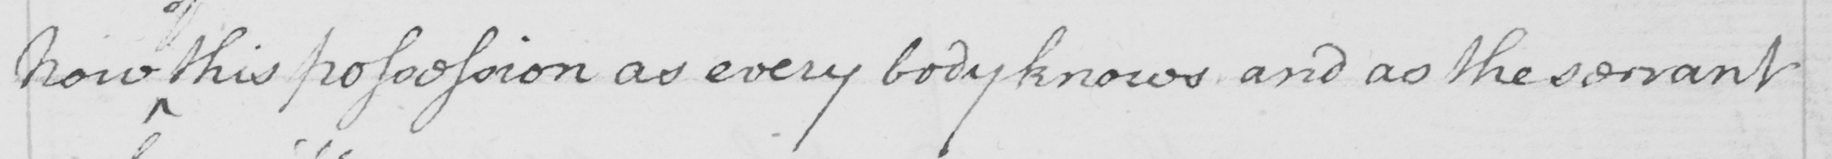What text is written in this handwritten line? Now this possession as everybody knows and as the servant 